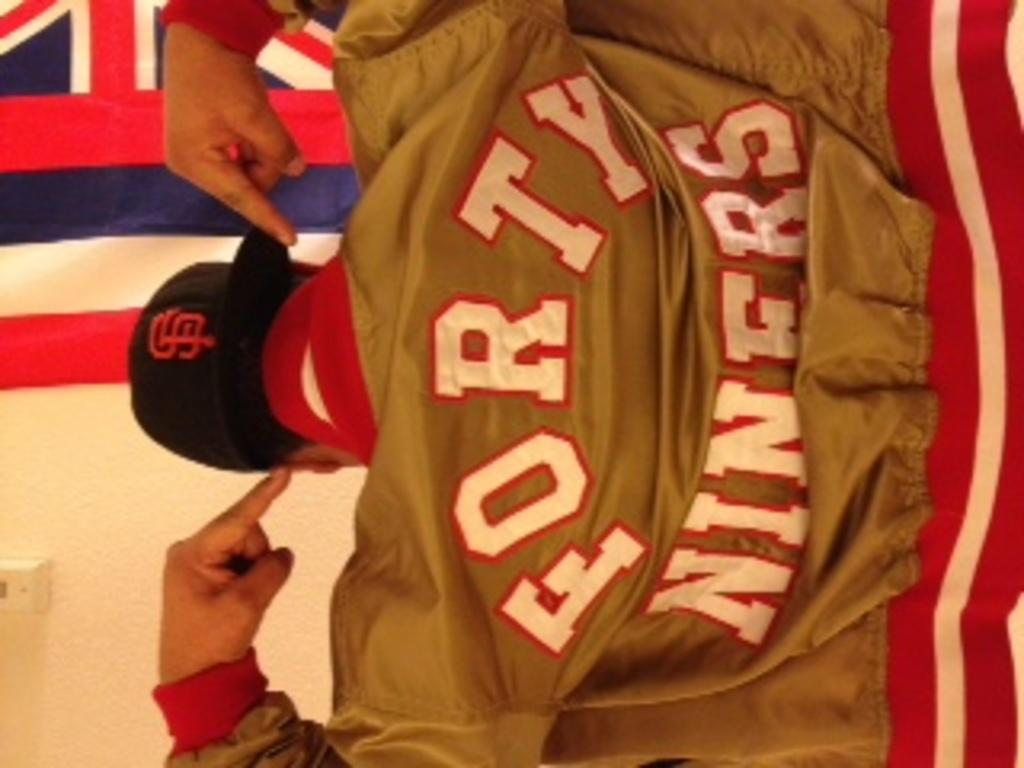Provide a one-sentence caption for the provided image. A man sits with his back to us and points to the Forty Niners wording on the back of his jacket. 